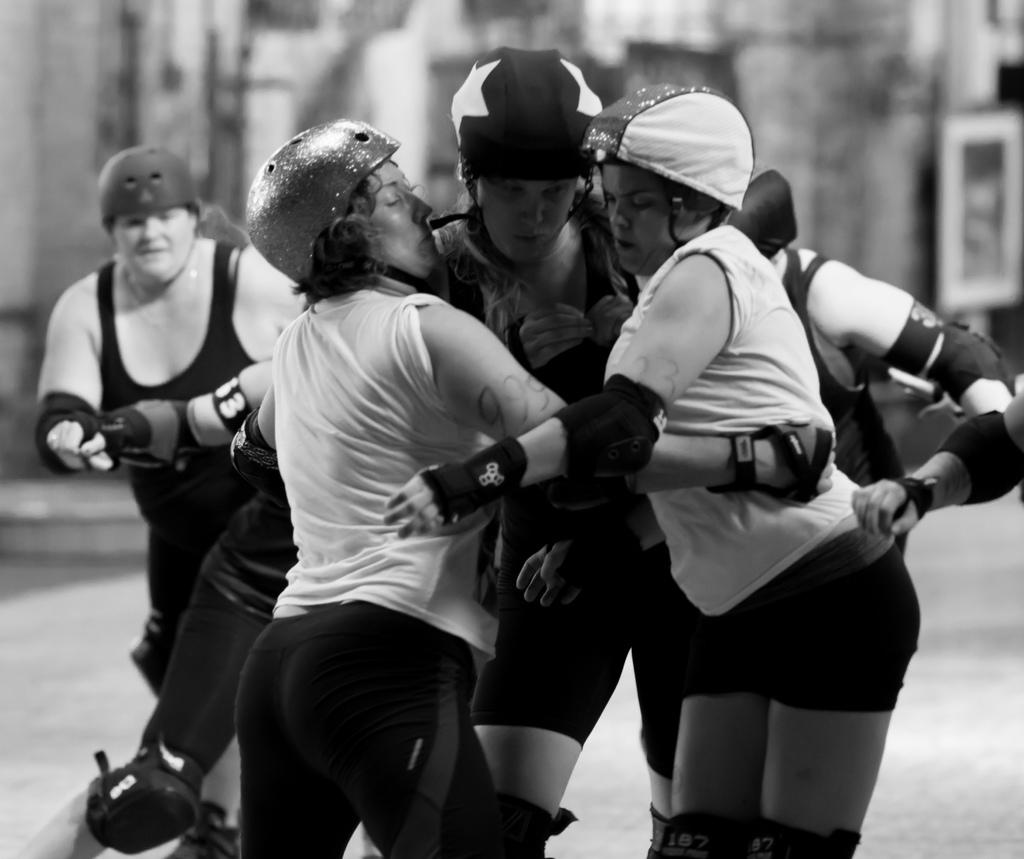How many people are in the image? There are persons in the image, but the exact number is not specified. What are the persons wearing? The persons are wearing clothes. What is the color scheme of the image? The image is black and white. Can you describe the background of the image? The background of the image is blurred. What type of snail can be seen crawling on the floor in the image? There is no snail or floor present in the image; it is a black and white image with blurred background and persons wearing clothes. 